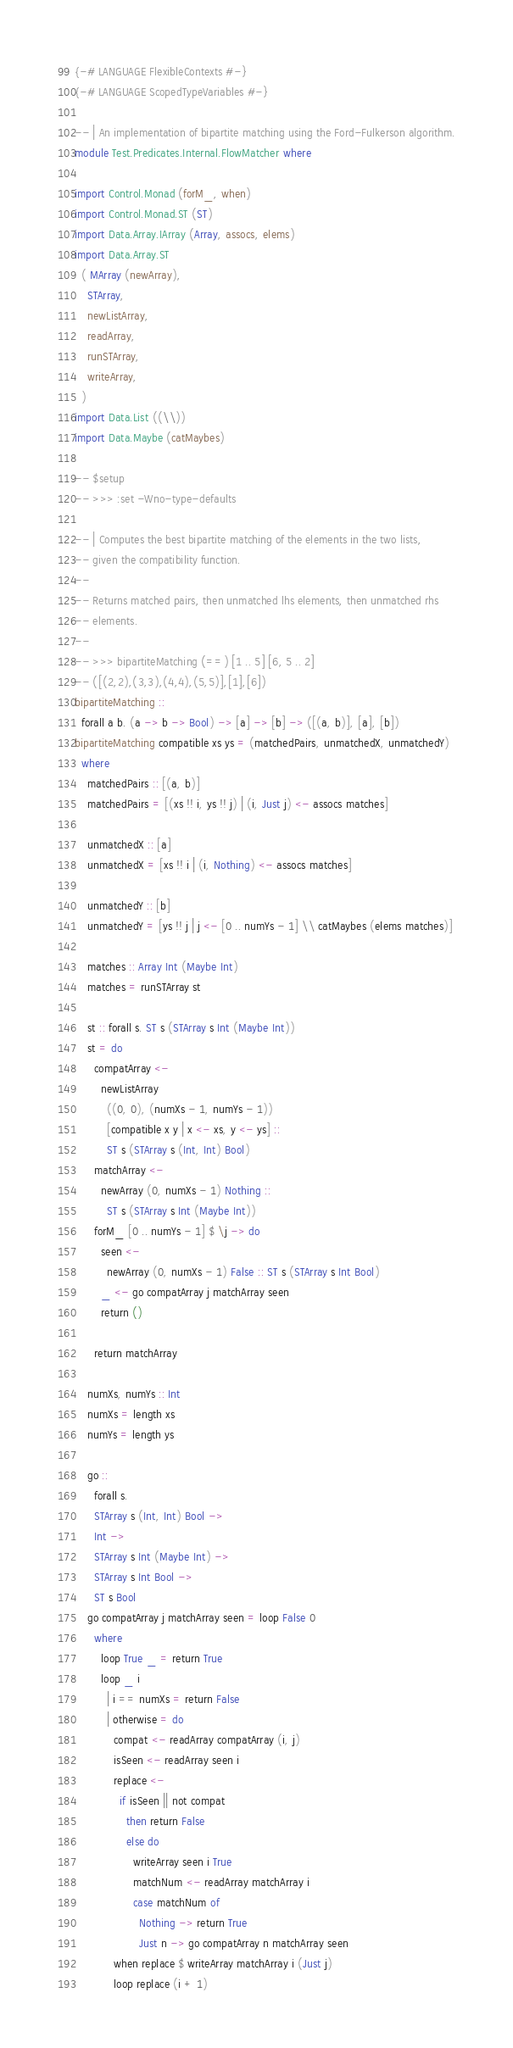Convert code to text. <code><loc_0><loc_0><loc_500><loc_500><_Haskell_>{-# LANGUAGE FlexibleContexts #-}
{-# LANGUAGE ScopedTypeVariables #-}

-- | An implementation of bipartite matching using the Ford-Fulkerson algorithm.
module Test.Predicates.Internal.FlowMatcher where

import Control.Monad (forM_, when)
import Control.Monad.ST (ST)
import Data.Array.IArray (Array, assocs, elems)
import Data.Array.ST
  ( MArray (newArray),
    STArray,
    newListArray,
    readArray,
    runSTArray,
    writeArray,
  )
import Data.List ((\\))
import Data.Maybe (catMaybes)

-- $setup
-- >>> :set -Wno-type-defaults

-- | Computes the best bipartite matching of the elements in the two lists,
-- given the compatibility function.
--
-- Returns matched pairs, then unmatched lhs elements, then unmatched rhs
-- elements.
--
-- >>> bipartiteMatching (==) [1 .. 5] [6, 5 .. 2]
-- ([(2,2),(3,3),(4,4),(5,5)],[1],[6])
bipartiteMatching ::
  forall a b. (a -> b -> Bool) -> [a] -> [b] -> ([(a, b)], [a], [b])
bipartiteMatching compatible xs ys = (matchedPairs, unmatchedX, unmatchedY)
  where
    matchedPairs :: [(a, b)]
    matchedPairs = [(xs !! i, ys !! j) | (i, Just j) <- assocs matches]

    unmatchedX :: [a]
    unmatchedX = [xs !! i | (i, Nothing) <- assocs matches]

    unmatchedY :: [b]
    unmatchedY = [ys !! j | j <- [0 .. numYs - 1] \\ catMaybes (elems matches)]

    matches :: Array Int (Maybe Int)
    matches = runSTArray st

    st :: forall s. ST s (STArray s Int (Maybe Int))
    st = do
      compatArray <-
        newListArray
          ((0, 0), (numXs - 1, numYs - 1))
          [compatible x y | x <- xs, y <- ys] ::
          ST s (STArray s (Int, Int) Bool)
      matchArray <-
        newArray (0, numXs - 1) Nothing ::
          ST s (STArray s Int (Maybe Int))
      forM_ [0 .. numYs - 1] $ \j -> do
        seen <-
          newArray (0, numXs - 1) False :: ST s (STArray s Int Bool)
        _ <- go compatArray j matchArray seen
        return ()

      return matchArray

    numXs, numYs :: Int
    numXs = length xs
    numYs = length ys

    go ::
      forall s.
      STArray s (Int, Int) Bool ->
      Int ->
      STArray s Int (Maybe Int) ->
      STArray s Int Bool ->
      ST s Bool
    go compatArray j matchArray seen = loop False 0
      where
        loop True _ = return True
        loop _ i
          | i == numXs = return False
          | otherwise = do
            compat <- readArray compatArray (i, j)
            isSeen <- readArray seen i
            replace <-
              if isSeen || not compat
                then return False
                else do
                  writeArray seen i True
                  matchNum <- readArray matchArray i
                  case matchNum of
                    Nothing -> return True
                    Just n -> go compatArray n matchArray seen
            when replace $ writeArray matchArray i (Just j)
            loop replace (i + 1)
</code> 